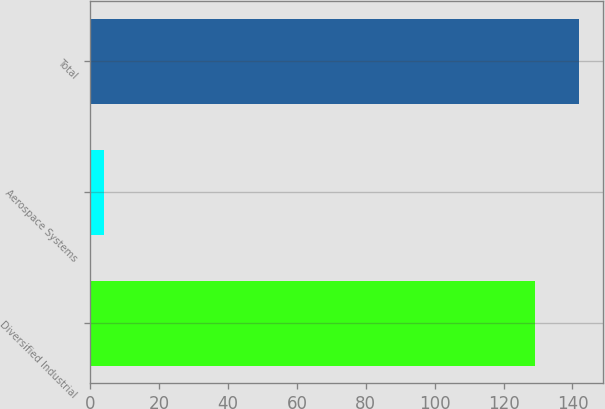<chart> <loc_0><loc_0><loc_500><loc_500><bar_chart><fcel>Diversified Industrial<fcel>Aerospace Systems<fcel>Total<nl><fcel>129<fcel>4<fcel>141.9<nl></chart> 